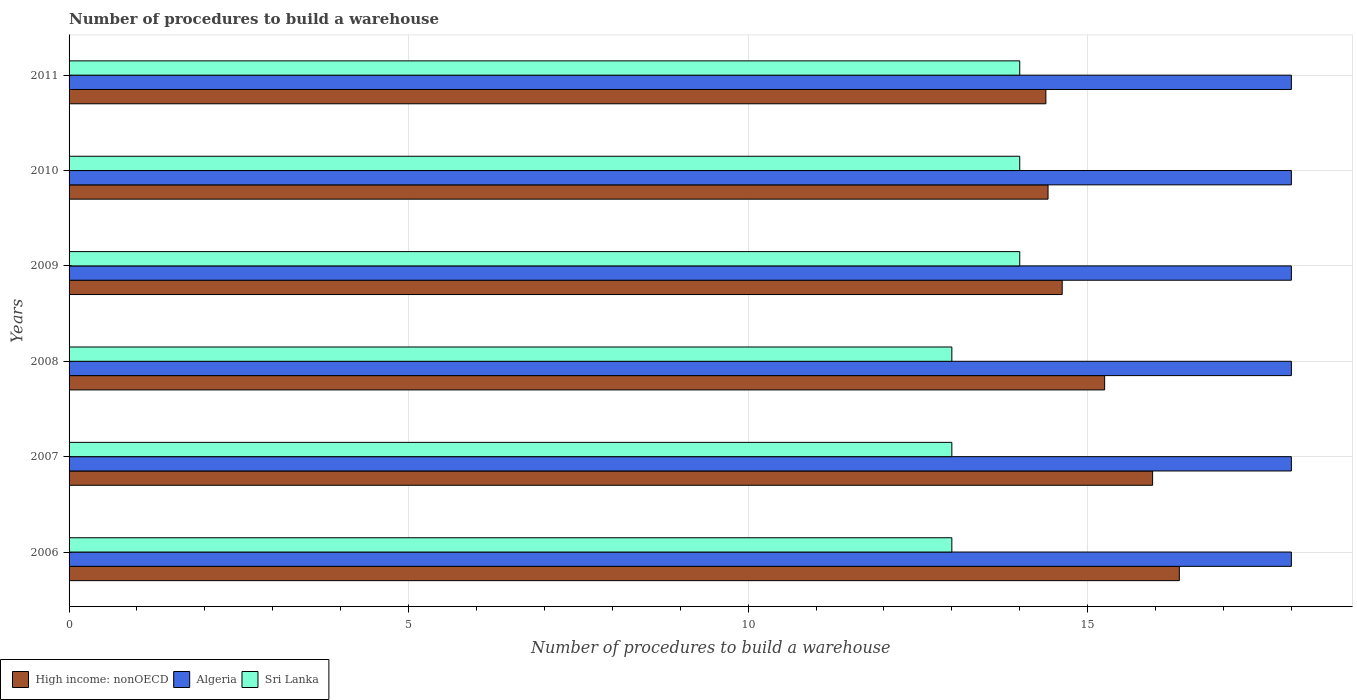Are the number of bars per tick equal to the number of legend labels?
Offer a terse response. Yes. Are the number of bars on each tick of the Y-axis equal?
Your response must be concise. Yes. What is the label of the 5th group of bars from the top?
Your response must be concise. 2007. In how many cases, is the number of bars for a given year not equal to the number of legend labels?
Give a very brief answer. 0. What is the number of procedures to build a warehouse in in Algeria in 2009?
Your response must be concise. 18. Across all years, what is the maximum number of procedures to build a warehouse in in Sri Lanka?
Ensure brevity in your answer.  14. Across all years, what is the minimum number of procedures to build a warehouse in in Algeria?
Ensure brevity in your answer.  18. In which year was the number of procedures to build a warehouse in in High income: nonOECD maximum?
Your answer should be very brief. 2006. In which year was the number of procedures to build a warehouse in in Algeria minimum?
Your answer should be very brief. 2006. What is the total number of procedures to build a warehouse in in High income: nonOECD in the graph?
Your answer should be very brief. 90.98. What is the difference between the number of procedures to build a warehouse in in High income: nonOECD in 2011 and the number of procedures to build a warehouse in in Sri Lanka in 2007?
Offer a very short reply. 1.38. What is the average number of procedures to build a warehouse in in Sri Lanka per year?
Your response must be concise. 13.5. In the year 2011, what is the difference between the number of procedures to build a warehouse in in Algeria and number of procedures to build a warehouse in in High income: nonOECD?
Your response must be concise. 3.62. In how many years, is the number of procedures to build a warehouse in in Sri Lanka greater than 1 ?
Provide a succinct answer. 6. What is the ratio of the number of procedures to build a warehouse in in Algeria in 2006 to that in 2009?
Your answer should be very brief. 1. Is the number of procedures to build a warehouse in in Sri Lanka in 2006 less than that in 2010?
Offer a terse response. Yes. What is the difference between the highest and the second highest number of procedures to build a warehouse in in Sri Lanka?
Offer a very short reply. 0. Is the sum of the number of procedures to build a warehouse in in Algeria in 2006 and 2009 greater than the maximum number of procedures to build a warehouse in in High income: nonOECD across all years?
Offer a terse response. Yes. What does the 2nd bar from the top in 2008 represents?
Offer a very short reply. Algeria. What does the 1st bar from the bottom in 2006 represents?
Your response must be concise. High income: nonOECD. Is it the case that in every year, the sum of the number of procedures to build a warehouse in in High income: nonOECD and number of procedures to build a warehouse in in Sri Lanka is greater than the number of procedures to build a warehouse in in Algeria?
Your answer should be very brief. Yes. Are the values on the major ticks of X-axis written in scientific E-notation?
Your response must be concise. No. Does the graph contain any zero values?
Make the answer very short. No. Does the graph contain grids?
Ensure brevity in your answer.  Yes. How many legend labels are there?
Your response must be concise. 3. How are the legend labels stacked?
Your response must be concise. Horizontal. What is the title of the graph?
Provide a succinct answer. Number of procedures to build a warehouse. What is the label or title of the X-axis?
Offer a very short reply. Number of procedures to build a warehouse. What is the Number of procedures to build a warehouse in High income: nonOECD in 2006?
Make the answer very short. 16.35. What is the Number of procedures to build a warehouse of Sri Lanka in 2006?
Keep it short and to the point. 13. What is the Number of procedures to build a warehouse in High income: nonOECD in 2007?
Your answer should be compact. 15.96. What is the Number of procedures to build a warehouse of Sri Lanka in 2007?
Offer a terse response. 13. What is the Number of procedures to build a warehouse in High income: nonOECD in 2008?
Provide a short and direct response. 15.25. What is the Number of procedures to build a warehouse of Algeria in 2008?
Ensure brevity in your answer.  18. What is the Number of procedures to build a warehouse in Sri Lanka in 2008?
Provide a succinct answer. 13. What is the Number of procedures to build a warehouse of High income: nonOECD in 2009?
Keep it short and to the point. 14.62. What is the Number of procedures to build a warehouse in High income: nonOECD in 2010?
Offer a terse response. 14.42. What is the Number of procedures to build a warehouse of Algeria in 2010?
Make the answer very short. 18. What is the Number of procedures to build a warehouse in Sri Lanka in 2010?
Ensure brevity in your answer.  14. What is the Number of procedures to build a warehouse in High income: nonOECD in 2011?
Provide a succinct answer. 14.38. What is the Number of procedures to build a warehouse of Algeria in 2011?
Ensure brevity in your answer.  18. What is the Number of procedures to build a warehouse of Sri Lanka in 2011?
Offer a terse response. 14. Across all years, what is the maximum Number of procedures to build a warehouse of High income: nonOECD?
Provide a short and direct response. 16.35. Across all years, what is the maximum Number of procedures to build a warehouse in Algeria?
Provide a succinct answer. 18. Across all years, what is the maximum Number of procedures to build a warehouse in Sri Lanka?
Your response must be concise. 14. Across all years, what is the minimum Number of procedures to build a warehouse in High income: nonOECD?
Give a very brief answer. 14.38. Across all years, what is the minimum Number of procedures to build a warehouse of Algeria?
Your response must be concise. 18. Across all years, what is the minimum Number of procedures to build a warehouse of Sri Lanka?
Your response must be concise. 13. What is the total Number of procedures to build a warehouse in High income: nonOECD in the graph?
Make the answer very short. 90.98. What is the total Number of procedures to build a warehouse in Algeria in the graph?
Provide a succinct answer. 108. What is the total Number of procedures to build a warehouse in Sri Lanka in the graph?
Provide a succinct answer. 81. What is the difference between the Number of procedures to build a warehouse in High income: nonOECD in 2006 and that in 2007?
Provide a succinct answer. 0.39. What is the difference between the Number of procedures to build a warehouse in High income: nonOECD in 2006 and that in 2008?
Your response must be concise. 1.1. What is the difference between the Number of procedures to build a warehouse in High income: nonOECD in 2006 and that in 2009?
Your answer should be compact. 1.73. What is the difference between the Number of procedures to build a warehouse of High income: nonOECD in 2006 and that in 2010?
Offer a terse response. 1.93. What is the difference between the Number of procedures to build a warehouse in Algeria in 2006 and that in 2010?
Offer a terse response. 0. What is the difference between the Number of procedures to build a warehouse in High income: nonOECD in 2006 and that in 2011?
Offer a very short reply. 1.97. What is the difference between the Number of procedures to build a warehouse in High income: nonOECD in 2007 and that in 2008?
Your answer should be compact. 0.71. What is the difference between the Number of procedures to build a warehouse of Algeria in 2007 and that in 2008?
Your answer should be compact. 0. What is the difference between the Number of procedures to build a warehouse of Sri Lanka in 2007 and that in 2008?
Offer a very short reply. 0. What is the difference between the Number of procedures to build a warehouse in High income: nonOECD in 2007 and that in 2009?
Ensure brevity in your answer.  1.33. What is the difference between the Number of procedures to build a warehouse of Sri Lanka in 2007 and that in 2009?
Keep it short and to the point. -1. What is the difference between the Number of procedures to build a warehouse of High income: nonOECD in 2007 and that in 2010?
Give a very brief answer. 1.54. What is the difference between the Number of procedures to build a warehouse of High income: nonOECD in 2007 and that in 2011?
Make the answer very short. 1.57. What is the difference between the Number of procedures to build a warehouse in High income: nonOECD in 2008 and that in 2009?
Offer a very short reply. 0.62. What is the difference between the Number of procedures to build a warehouse in Algeria in 2008 and that in 2009?
Give a very brief answer. 0. What is the difference between the Number of procedures to build a warehouse of Sri Lanka in 2008 and that in 2009?
Offer a very short reply. -1. What is the difference between the Number of procedures to build a warehouse of Algeria in 2008 and that in 2010?
Offer a very short reply. 0. What is the difference between the Number of procedures to build a warehouse in Sri Lanka in 2008 and that in 2010?
Give a very brief answer. -1. What is the difference between the Number of procedures to build a warehouse in High income: nonOECD in 2008 and that in 2011?
Offer a terse response. 0.87. What is the difference between the Number of procedures to build a warehouse in Sri Lanka in 2008 and that in 2011?
Keep it short and to the point. -1. What is the difference between the Number of procedures to build a warehouse of High income: nonOECD in 2009 and that in 2010?
Your answer should be compact. 0.21. What is the difference between the Number of procedures to build a warehouse of Sri Lanka in 2009 and that in 2010?
Your answer should be compact. 0. What is the difference between the Number of procedures to build a warehouse of High income: nonOECD in 2009 and that in 2011?
Offer a terse response. 0.24. What is the difference between the Number of procedures to build a warehouse of Algeria in 2009 and that in 2011?
Give a very brief answer. 0. What is the difference between the Number of procedures to build a warehouse of High income: nonOECD in 2010 and that in 2011?
Keep it short and to the point. 0.03. What is the difference between the Number of procedures to build a warehouse of Algeria in 2010 and that in 2011?
Give a very brief answer. 0. What is the difference between the Number of procedures to build a warehouse of Sri Lanka in 2010 and that in 2011?
Offer a terse response. 0. What is the difference between the Number of procedures to build a warehouse of High income: nonOECD in 2006 and the Number of procedures to build a warehouse of Algeria in 2007?
Offer a terse response. -1.65. What is the difference between the Number of procedures to build a warehouse of High income: nonOECD in 2006 and the Number of procedures to build a warehouse of Sri Lanka in 2007?
Provide a short and direct response. 3.35. What is the difference between the Number of procedures to build a warehouse of Algeria in 2006 and the Number of procedures to build a warehouse of Sri Lanka in 2007?
Your answer should be compact. 5. What is the difference between the Number of procedures to build a warehouse of High income: nonOECD in 2006 and the Number of procedures to build a warehouse of Algeria in 2008?
Provide a short and direct response. -1.65. What is the difference between the Number of procedures to build a warehouse of High income: nonOECD in 2006 and the Number of procedures to build a warehouse of Sri Lanka in 2008?
Provide a succinct answer. 3.35. What is the difference between the Number of procedures to build a warehouse of Algeria in 2006 and the Number of procedures to build a warehouse of Sri Lanka in 2008?
Provide a short and direct response. 5. What is the difference between the Number of procedures to build a warehouse of High income: nonOECD in 2006 and the Number of procedures to build a warehouse of Algeria in 2009?
Ensure brevity in your answer.  -1.65. What is the difference between the Number of procedures to build a warehouse of High income: nonOECD in 2006 and the Number of procedures to build a warehouse of Sri Lanka in 2009?
Offer a terse response. 2.35. What is the difference between the Number of procedures to build a warehouse of Algeria in 2006 and the Number of procedures to build a warehouse of Sri Lanka in 2009?
Your answer should be compact. 4. What is the difference between the Number of procedures to build a warehouse of High income: nonOECD in 2006 and the Number of procedures to build a warehouse of Algeria in 2010?
Make the answer very short. -1.65. What is the difference between the Number of procedures to build a warehouse of High income: nonOECD in 2006 and the Number of procedures to build a warehouse of Sri Lanka in 2010?
Your answer should be very brief. 2.35. What is the difference between the Number of procedures to build a warehouse in Algeria in 2006 and the Number of procedures to build a warehouse in Sri Lanka in 2010?
Offer a terse response. 4. What is the difference between the Number of procedures to build a warehouse of High income: nonOECD in 2006 and the Number of procedures to build a warehouse of Algeria in 2011?
Your answer should be very brief. -1.65. What is the difference between the Number of procedures to build a warehouse in High income: nonOECD in 2006 and the Number of procedures to build a warehouse in Sri Lanka in 2011?
Provide a short and direct response. 2.35. What is the difference between the Number of procedures to build a warehouse in High income: nonOECD in 2007 and the Number of procedures to build a warehouse in Algeria in 2008?
Your answer should be compact. -2.04. What is the difference between the Number of procedures to build a warehouse of High income: nonOECD in 2007 and the Number of procedures to build a warehouse of Sri Lanka in 2008?
Give a very brief answer. 2.96. What is the difference between the Number of procedures to build a warehouse of High income: nonOECD in 2007 and the Number of procedures to build a warehouse of Algeria in 2009?
Ensure brevity in your answer.  -2.04. What is the difference between the Number of procedures to build a warehouse in High income: nonOECD in 2007 and the Number of procedures to build a warehouse in Sri Lanka in 2009?
Offer a very short reply. 1.96. What is the difference between the Number of procedures to build a warehouse in Algeria in 2007 and the Number of procedures to build a warehouse in Sri Lanka in 2009?
Your answer should be very brief. 4. What is the difference between the Number of procedures to build a warehouse of High income: nonOECD in 2007 and the Number of procedures to build a warehouse of Algeria in 2010?
Provide a succinct answer. -2.04. What is the difference between the Number of procedures to build a warehouse in High income: nonOECD in 2007 and the Number of procedures to build a warehouse in Sri Lanka in 2010?
Make the answer very short. 1.96. What is the difference between the Number of procedures to build a warehouse of High income: nonOECD in 2007 and the Number of procedures to build a warehouse of Algeria in 2011?
Offer a very short reply. -2.04. What is the difference between the Number of procedures to build a warehouse in High income: nonOECD in 2007 and the Number of procedures to build a warehouse in Sri Lanka in 2011?
Your response must be concise. 1.96. What is the difference between the Number of procedures to build a warehouse in Algeria in 2007 and the Number of procedures to build a warehouse in Sri Lanka in 2011?
Ensure brevity in your answer.  4. What is the difference between the Number of procedures to build a warehouse of High income: nonOECD in 2008 and the Number of procedures to build a warehouse of Algeria in 2009?
Your response must be concise. -2.75. What is the difference between the Number of procedures to build a warehouse of High income: nonOECD in 2008 and the Number of procedures to build a warehouse of Sri Lanka in 2009?
Make the answer very short. 1.25. What is the difference between the Number of procedures to build a warehouse in High income: nonOECD in 2008 and the Number of procedures to build a warehouse in Algeria in 2010?
Provide a short and direct response. -2.75. What is the difference between the Number of procedures to build a warehouse of High income: nonOECD in 2008 and the Number of procedures to build a warehouse of Sri Lanka in 2010?
Keep it short and to the point. 1.25. What is the difference between the Number of procedures to build a warehouse in Algeria in 2008 and the Number of procedures to build a warehouse in Sri Lanka in 2010?
Offer a very short reply. 4. What is the difference between the Number of procedures to build a warehouse in High income: nonOECD in 2008 and the Number of procedures to build a warehouse in Algeria in 2011?
Your answer should be very brief. -2.75. What is the difference between the Number of procedures to build a warehouse of High income: nonOECD in 2008 and the Number of procedures to build a warehouse of Sri Lanka in 2011?
Offer a very short reply. 1.25. What is the difference between the Number of procedures to build a warehouse of Algeria in 2008 and the Number of procedures to build a warehouse of Sri Lanka in 2011?
Provide a short and direct response. 4. What is the difference between the Number of procedures to build a warehouse of High income: nonOECD in 2009 and the Number of procedures to build a warehouse of Algeria in 2010?
Your answer should be compact. -3.38. What is the difference between the Number of procedures to build a warehouse in High income: nonOECD in 2009 and the Number of procedures to build a warehouse in Algeria in 2011?
Offer a terse response. -3.38. What is the difference between the Number of procedures to build a warehouse in High income: nonOECD in 2010 and the Number of procedures to build a warehouse in Algeria in 2011?
Your response must be concise. -3.58. What is the difference between the Number of procedures to build a warehouse of High income: nonOECD in 2010 and the Number of procedures to build a warehouse of Sri Lanka in 2011?
Offer a very short reply. 0.42. What is the difference between the Number of procedures to build a warehouse of Algeria in 2010 and the Number of procedures to build a warehouse of Sri Lanka in 2011?
Your answer should be very brief. 4. What is the average Number of procedures to build a warehouse in High income: nonOECD per year?
Provide a succinct answer. 15.16. What is the average Number of procedures to build a warehouse in Algeria per year?
Give a very brief answer. 18. What is the average Number of procedures to build a warehouse of Sri Lanka per year?
Offer a very short reply. 13.5. In the year 2006, what is the difference between the Number of procedures to build a warehouse in High income: nonOECD and Number of procedures to build a warehouse in Algeria?
Give a very brief answer. -1.65. In the year 2006, what is the difference between the Number of procedures to build a warehouse of High income: nonOECD and Number of procedures to build a warehouse of Sri Lanka?
Give a very brief answer. 3.35. In the year 2007, what is the difference between the Number of procedures to build a warehouse of High income: nonOECD and Number of procedures to build a warehouse of Algeria?
Your response must be concise. -2.04. In the year 2007, what is the difference between the Number of procedures to build a warehouse in High income: nonOECD and Number of procedures to build a warehouse in Sri Lanka?
Make the answer very short. 2.96. In the year 2007, what is the difference between the Number of procedures to build a warehouse of Algeria and Number of procedures to build a warehouse of Sri Lanka?
Offer a terse response. 5. In the year 2008, what is the difference between the Number of procedures to build a warehouse in High income: nonOECD and Number of procedures to build a warehouse in Algeria?
Offer a terse response. -2.75. In the year 2008, what is the difference between the Number of procedures to build a warehouse of High income: nonOECD and Number of procedures to build a warehouse of Sri Lanka?
Make the answer very short. 2.25. In the year 2009, what is the difference between the Number of procedures to build a warehouse of High income: nonOECD and Number of procedures to build a warehouse of Algeria?
Keep it short and to the point. -3.38. In the year 2009, what is the difference between the Number of procedures to build a warehouse of Algeria and Number of procedures to build a warehouse of Sri Lanka?
Keep it short and to the point. 4. In the year 2010, what is the difference between the Number of procedures to build a warehouse of High income: nonOECD and Number of procedures to build a warehouse of Algeria?
Your answer should be compact. -3.58. In the year 2010, what is the difference between the Number of procedures to build a warehouse of High income: nonOECD and Number of procedures to build a warehouse of Sri Lanka?
Provide a succinct answer. 0.42. In the year 2011, what is the difference between the Number of procedures to build a warehouse in High income: nonOECD and Number of procedures to build a warehouse in Algeria?
Ensure brevity in your answer.  -3.62. In the year 2011, what is the difference between the Number of procedures to build a warehouse of High income: nonOECD and Number of procedures to build a warehouse of Sri Lanka?
Give a very brief answer. 0.38. In the year 2011, what is the difference between the Number of procedures to build a warehouse of Algeria and Number of procedures to build a warehouse of Sri Lanka?
Keep it short and to the point. 4. What is the ratio of the Number of procedures to build a warehouse in High income: nonOECD in 2006 to that in 2007?
Ensure brevity in your answer.  1.02. What is the ratio of the Number of procedures to build a warehouse of Algeria in 2006 to that in 2007?
Provide a short and direct response. 1. What is the ratio of the Number of procedures to build a warehouse of High income: nonOECD in 2006 to that in 2008?
Keep it short and to the point. 1.07. What is the ratio of the Number of procedures to build a warehouse in Algeria in 2006 to that in 2008?
Your response must be concise. 1. What is the ratio of the Number of procedures to build a warehouse of High income: nonOECD in 2006 to that in 2009?
Your answer should be compact. 1.12. What is the ratio of the Number of procedures to build a warehouse of Sri Lanka in 2006 to that in 2009?
Ensure brevity in your answer.  0.93. What is the ratio of the Number of procedures to build a warehouse in High income: nonOECD in 2006 to that in 2010?
Keep it short and to the point. 1.13. What is the ratio of the Number of procedures to build a warehouse of Algeria in 2006 to that in 2010?
Give a very brief answer. 1. What is the ratio of the Number of procedures to build a warehouse of High income: nonOECD in 2006 to that in 2011?
Make the answer very short. 1.14. What is the ratio of the Number of procedures to build a warehouse of Sri Lanka in 2006 to that in 2011?
Offer a terse response. 0.93. What is the ratio of the Number of procedures to build a warehouse in High income: nonOECD in 2007 to that in 2008?
Offer a terse response. 1.05. What is the ratio of the Number of procedures to build a warehouse of Sri Lanka in 2007 to that in 2008?
Offer a terse response. 1. What is the ratio of the Number of procedures to build a warehouse of High income: nonOECD in 2007 to that in 2009?
Keep it short and to the point. 1.09. What is the ratio of the Number of procedures to build a warehouse of Algeria in 2007 to that in 2009?
Keep it short and to the point. 1. What is the ratio of the Number of procedures to build a warehouse in High income: nonOECD in 2007 to that in 2010?
Offer a terse response. 1.11. What is the ratio of the Number of procedures to build a warehouse of Algeria in 2007 to that in 2010?
Provide a short and direct response. 1. What is the ratio of the Number of procedures to build a warehouse in Sri Lanka in 2007 to that in 2010?
Ensure brevity in your answer.  0.93. What is the ratio of the Number of procedures to build a warehouse in High income: nonOECD in 2007 to that in 2011?
Give a very brief answer. 1.11. What is the ratio of the Number of procedures to build a warehouse in High income: nonOECD in 2008 to that in 2009?
Provide a succinct answer. 1.04. What is the ratio of the Number of procedures to build a warehouse in Sri Lanka in 2008 to that in 2009?
Keep it short and to the point. 0.93. What is the ratio of the Number of procedures to build a warehouse in High income: nonOECD in 2008 to that in 2010?
Offer a very short reply. 1.06. What is the ratio of the Number of procedures to build a warehouse in Algeria in 2008 to that in 2010?
Offer a terse response. 1. What is the ratio of the Number of procedures to build a warehouse in Sri Lanka in 2008 to that in 2010?
Give a very brief answer. 0.93. What is the ratio of the Number of procedures to build a warehouse in High income: nonOECD in 2008 to that in 2011?
Offer a terse response. 1.06. What is the ratio of the Number of procedures to build a warehouse of Algeria in 2008 to that in 2011?
Ensure brevity in your answer.  1. What is the ratio of the Number of procedures to build a warehouse in High income: nonOECD in 2009 to that in 2010?
Offer a terse response. 1.01. What is the ratio of the Number of procedures to build a warehouse in High income: nonOECD in 2009 to that in 2011?
Offer a very short reply. 1.02. What is the ratio of the Number of procedures to build a warehouse in Sri Lanka in 2009 to that in 2011?
Offer a very short reply. 1. What is the ratio of the Number of procedures to build a warehouse in High income: nonOECD in 2010 to that in 2011?
Make the answer very short. 1. What is the ratio of the Number of procedures to build a warehouse of Algeria in 2010 to that in 2011?
Provide a short and direct response. 1. What is the ratio of the Number of procedures to build a warehouse of Sri Lanka in 2010 to that in 2011?
Keep it short and to the point. 1. What is the difference between the highest and the second highest Number of procedures to build a warehouse of High income: nonOECD?
Your answer should be very brief. 0.39. What is the difference between the highest and the second highest Number of procedures to build a warehouse in Algeria?
Your response must be concise. 0. What is the difference between the highest and the lowest Number of procedures to build a warehouse of High income: nonOECD?
Your answer should be very brief. 1.97. 